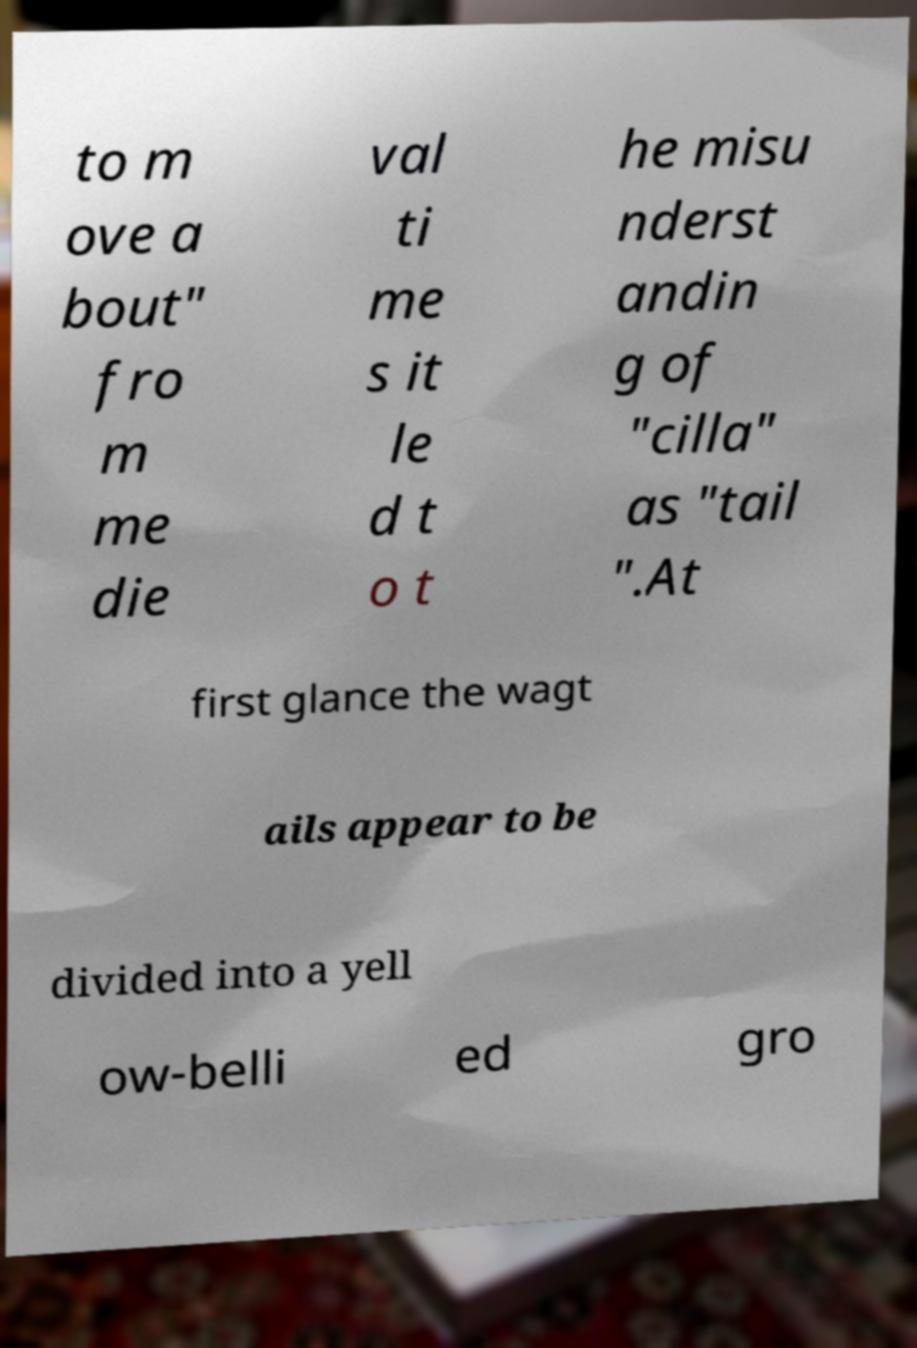I need the written content from this picture converted into text. Can you do that? to m ove a bout" fro m me die val ti me s it le d t o t he misu nderst andin g of "cilla" as "tail ".At first glance the wagt ails appear to be divided into a yell ow-belli ed gro 